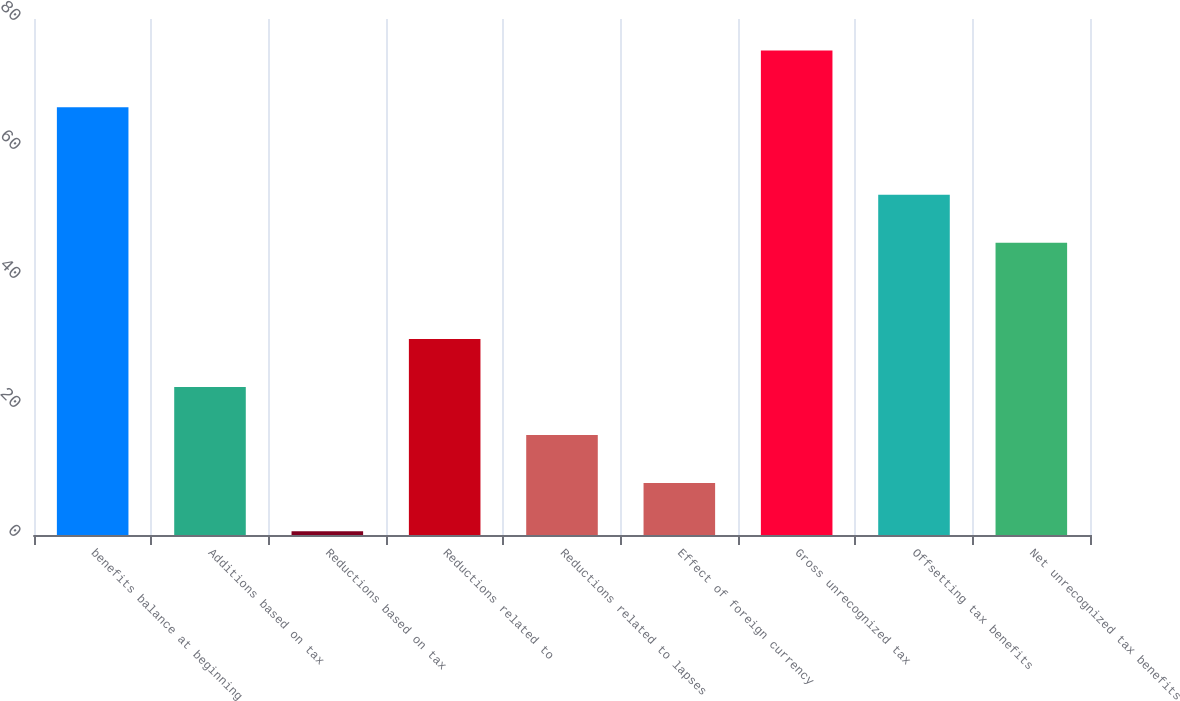Convert chart. <chart><loc_0><loc_0><loc_500><loc_500><bar_chart><fcel>benefits balance at beginning<fcel>Additions based on tax<fcel>Reductions based on tax<fcel>Reductions related to<fcel>Reductions related to lapses<fcel>Effect of foreign currency<fcel>Gross unrecognized tax<fcel>Offsetting tax benefits<fcel>Net unrecognized tax benefits<nl><fcel>66.3<fcel>22.95<fcel>0.6<fcel>30.4<fcel>15.5<fcel>8.05<fcel>75.1<fcel>52.75<fcel>45.3<nl></chart> 